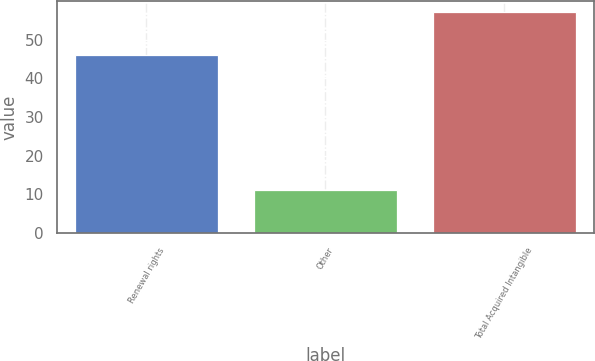<chart> <loc_0><loc_0><loc_500><loc_500><bar_chart><fcel>Renewal rights<fcel>Other<fcel>Total Acquired Intangible<nl><fcel>46<fcel>11<fcel>57<nl></chart> 